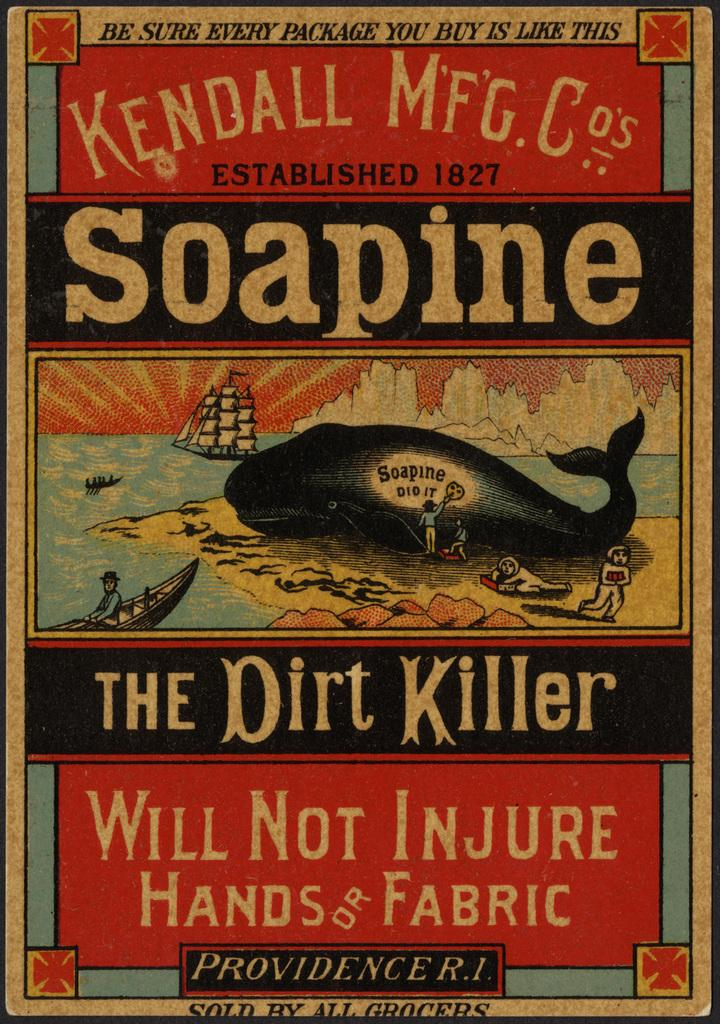<image>
Render a clear and concise summary of the photo. A colorful old Kendall advertising sign which says their product is "The Dirt Killer". 